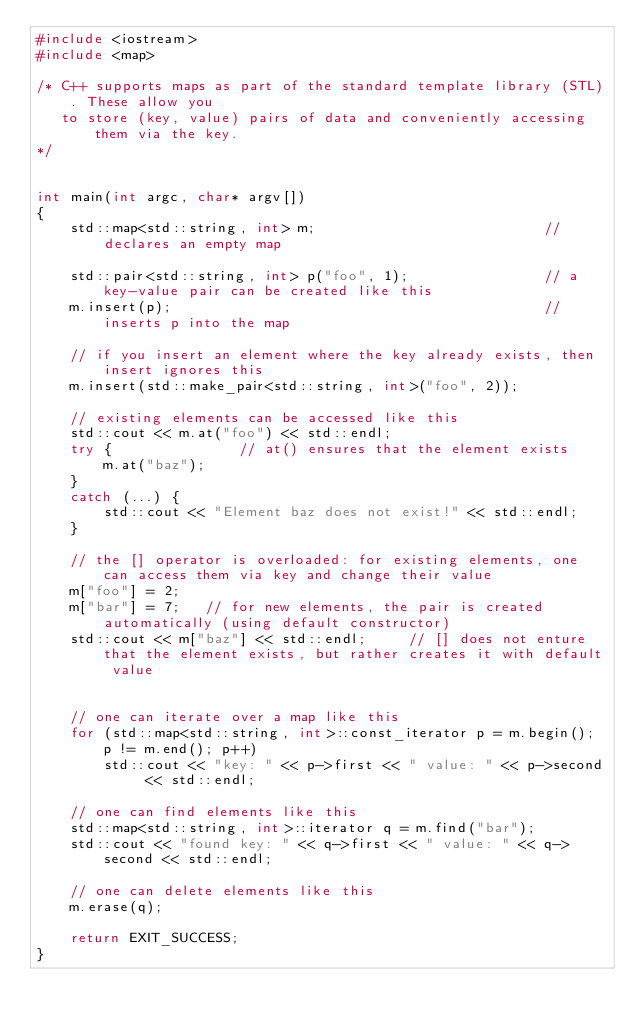<code> <loc_0><loc_0><loc_500><loc_500><_C++_>#include <iostream>
#include <map>

/* C++ supports maps as part of the standard template library (STL). These allow you
   to store (key, value) pairs of data and conveniently accessing them via the key.
*/


int main(int argc, char* argv[])
{
    std::map<std::string, int> m;                           // declares an empty map

    std::pair<std::string, int> p("foo", 1);                // a key-value pair can be created like this
    m.insert(p);                                            // inserts p into the map

    // if you insert an element where the key already exists, then insert ignores this
    m.insert(std::make_pair<std::string, int>("foo", 2));
    
    // existing elements can be accessed like this
    std::cout << m.at("foo") << std::endl;
    try {               // at() ensures that the element exists
        m.at("baz");
    }
    catch (...) {
        std::cout << "Element baz does not exist!" << std::endl;
    }

    // the [] operator is overloaded: for existing elements, one can access them via key and change their value
    m["foo"] = 2;
    m["bar"] = 7;   // for new elements, the pair is created automatically (using default constructor)
    std::cout << m["baz"] << std::endl;     // [] does not enture that the element exists, but rather creates it with default value


    // one can iterate over a map like this
    for (std::map<std::string, int>::const_iterator p = m.begin(); p != m.end(); p++)
        std::cout << "key: " << p->first << " value: " << p->second << std::endl;

    // one can find elements like this
    std::map<std::string, int>::iterator q = m.find("bar");
    std::cout << "found key: " << q->first << " value: " << q->second << std::endl;

    // one can delete elements like this
    m.erase(q);

    return EXIT_SUCCESS;
}
</code> 